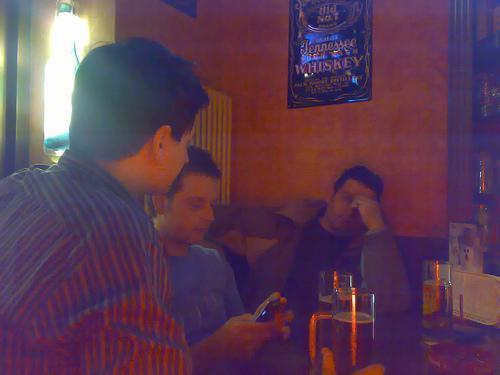How many people are reading book?
Give a very brief answer. 0. 